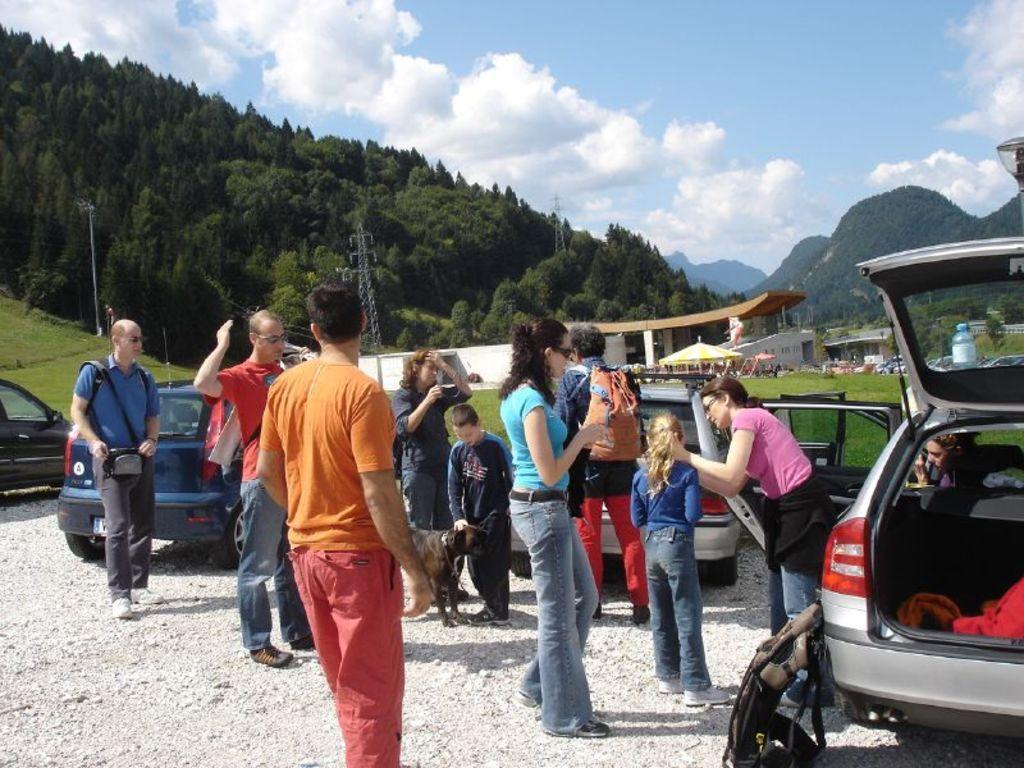Please provide a concise description of this image. This picture is clicked outside. In the center we can see the group of people standing on the ground and we can see an animal standing on the ground and we can see the backpack and the cars parked on the ground and some objects. In the center we can see the green grass, tent, metal rods and some objects. In the background we can see the sky with the clouds and we can see the hills, trees and many other objects. 